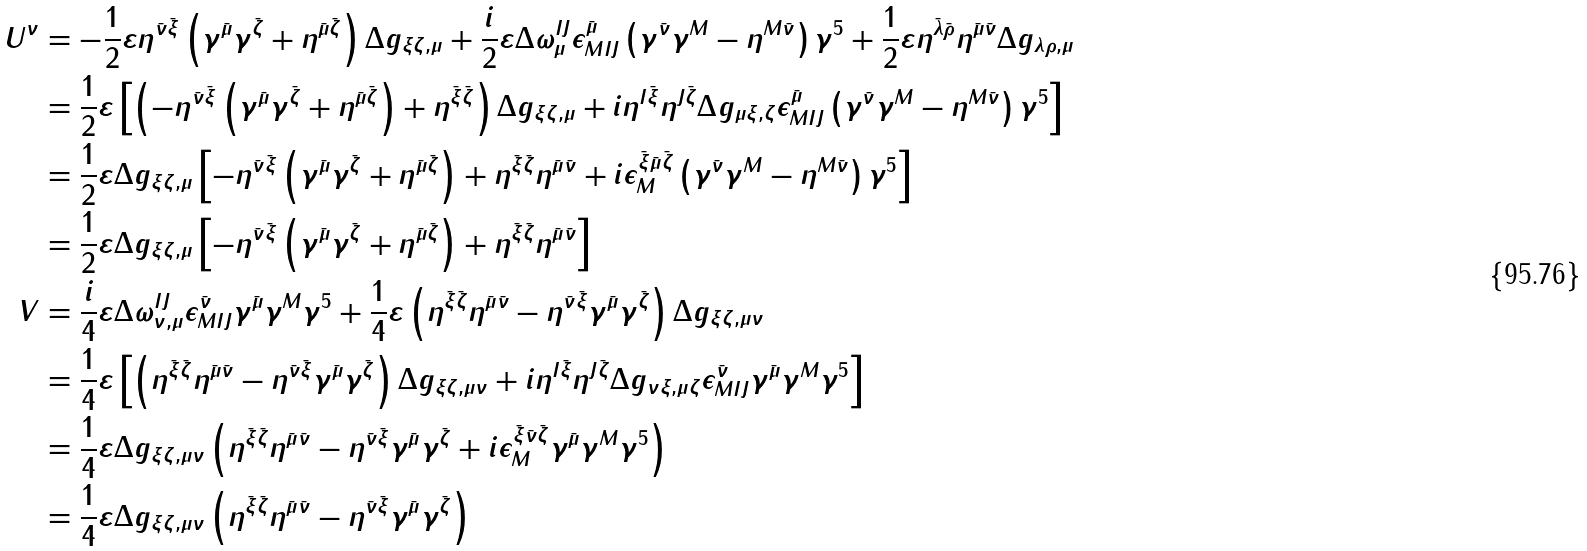<formula> <loc_0><loc_0><loc_500><loc_500>U ^ { \nu } & = - \frac { 1 } { 2 } \varepsilon \eta ^ { \bar { \nu } \bar { \xi } } \left ( \gamma ^ { \bar { \mu } } \gamma ^ { \bar { \zeta } } + \eta ^ { \bar { \mu } \bar { \zeta } } \right ) \Delta g _ { \xi \zeta , \mu } + \frac { i } { 2 } \varepsilon \Delta \omega ^ { I J } _ { \mu } \epsilon _ { M I J } ^ { \bar { \mu } } \left ( \gamma ^ { \bar { \nu } } \gamma ^ { M } - \eta ^ { M \bar { \nu } } \right ) \gamma ^ { 5 } + \frac { 1 } { 2 } \varepsilon \eta ^ { \bar { \lambda } \bar { \rho } } \eta ^ { \bar { \mu } \bar { \nu } } \Delta g _ { \lambda \rho , \mu } \\ & = \frac { 1 } { 2 } \varepsilon \left [ \left ( - \eta ^ { \bar { \nu } \bar { \xi } } \left ( \gamma ^ { \bar { \mu } } \gamma ^ { \bar { \zeta } } + \eta ^ { \bar { \mu } \bar { \zeta } } \right ) + \eta ^ { \bar { \xi } \bar { \zeta } } \right ) \Delta g _ { \xi \zeta , \mu } + i \eta ^ { I \bar { \xi } } \eta ^ { J \bar { \zeta } } \Delta g _ { \mu \xi , \zeta } \epsilon _ { M I J } ^ { \bar { \mu } } \left ( \gamma ^ { \bar { \nu } } \gamma ^ { M } - \eta ^ { M \bar { \nu } } \right ) \gamma ^ { 5 } \right ] \\ & = \frac { 1 } { 2 } \varepsilon \Delta g _ { \xi \zeta , \mu } \left [ - \eta ^ { \bar { \nu } \bar { \xi } } \left ( \gamma ^ { \bar { \mu } } \gamma ^ { \bar { \zeta } } + \eta ^ { \bar { \mu } \bar { \zeta } } \right ) + \eta ^ { \bar { \xi } \bar { \zeta } } \eta ^ { \bar { \mu } \bar { \nu } } + i \epsilon _ { M } ^ { \bar { \xi } \bar { \mu } \bar { \zeta } } \left ( \gamma ^ { \bar { \nu } } \gamma ^ { M } - \eta ^ { M \bar { \nu } } \right ) \gamma ^ { 5 } \right ] \\ & = \frac { 1 } { 2 } \varepsilon \Delta g _ { \xi \zeta , \mu } \left [ - \eta ^ { \bar { \nu } \bar { \xi } } \left ( \gamma ^ { \bar { \mu } } \gamma ^ { \bar { \zeta } } + \eta ^ { \bar { \mu } \bar { \zeta } } \right ) + \eta ^ { \bar { \xi } \bar { \zeta } } \eta ^ { \bar { \mu } \bar { \nu } } \right ] \\ V & = \frac { i } { 4 } \varepsilon \Delta \omega ^ { I J } _ { \nu , \mu } \epsilon _ { M I J } ^ { \bar { \nu } } \gamma ^ { \bar { \mu } } \gamma ^ { M } \gamma ^ { 5 } + \frac { 1 } { 4 } \varepsilon \left ( \eta ^ { \bar { \xi } \bar { \zeta } } \eta ^ { \bar { \mu } \bar { \nu } } - \eta ^ { \bar { \nu } \bar { \xi } } \gamma ^ { \bar { \mu } } \gamma ^ { \bar { \zeta } } \right ) \Delta g _ { \xi \zeta , \mu \nu } \\ & = \frac { 1 } { 4 } \varepsilon \left [ \left ( \eta ^ { \bar { \xi } \bar { \zeta } } \eta ^ { \bar { \mu } \bar { \nu } } - \eta ^ { \bar { \nu } \bar { \xi } } \gamma ^ { \bar { \mu } } \gamma ^ { \bar { \zeta } } \right ) \Delta g _ { \xi \zeta , \mu \nu } + i \eta ^ { I \bar { \xi } } \eta ^ { J \bar { \zeta } } \Delta g _ { \nu \xi , \mu \zeta } \epsilon _ { M I J } ^ { \bar { \nu } } \gamma ^ { \bar { \mu } } \gamma ^ { M } \gamma ^ { 5 } \right ] \\ & = \frac { 1 } { 4 } \varepsilon \Delta g _ { \xi \zeta , \mu \nu } \left ( \eta ^ { \bar { \xi } \bar { \zeta } } \eta ^ { \bar { \mu } \bar { \nu } } - \eta ^ { \bar { \nu } \bar { \xi } } \gamma ^ { \bar { \mu } } \gamma ^ { \bar { \zeta } } + i \epsilon _ { M } ^ { \bar { \xi } \bar { \nu } \bar { \zeta } } \gamma ^ { \bar { \mu } } \gamma ^ { M } \gamma ^ { 5 } \right ) \\ & = \frac { 1 } { 4 } \varepsilon \Delta g _ { \xi \zeta , \mu \nu } \left ( \eta ^ { \bar { \xi } \bar { \zeta } } \eta ^ { \bar { \mu } \bar { \nu } } - \eta ^ { \bar { \nu } \bar { \xi } } \gamma ^ { \bar { \mu } } \gamma ^ { \bar { \zeta } } \right )</formula> 